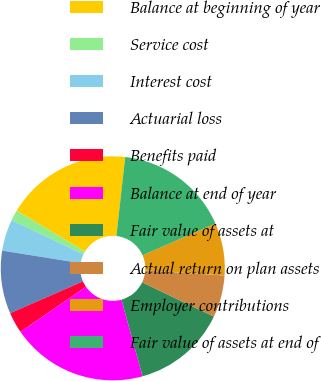<chart> <loc_0><loc_0><loc_500><loc_500><pie_chart><fcel>Balance at beginning of year<fcel>Service cost<fcel>Interest cost<fcel>Actuarial loss<fcel>Benefits paid<fcel>Balance at end of year<fcel>Fair value of assets at<fcel>Actual return on plan assets<fcel>Employer contributions<fcel>Fair value of assets at end of<nl><fcel>18.18%<fcel>1.52%<fcel>4.55%<fcel>9.09%<fcel>3.03%<fcel>19.69%<fcel>13.64%<fcel>6.06%<fcel>7.58%<fcel>16.67%<nl></chart> 